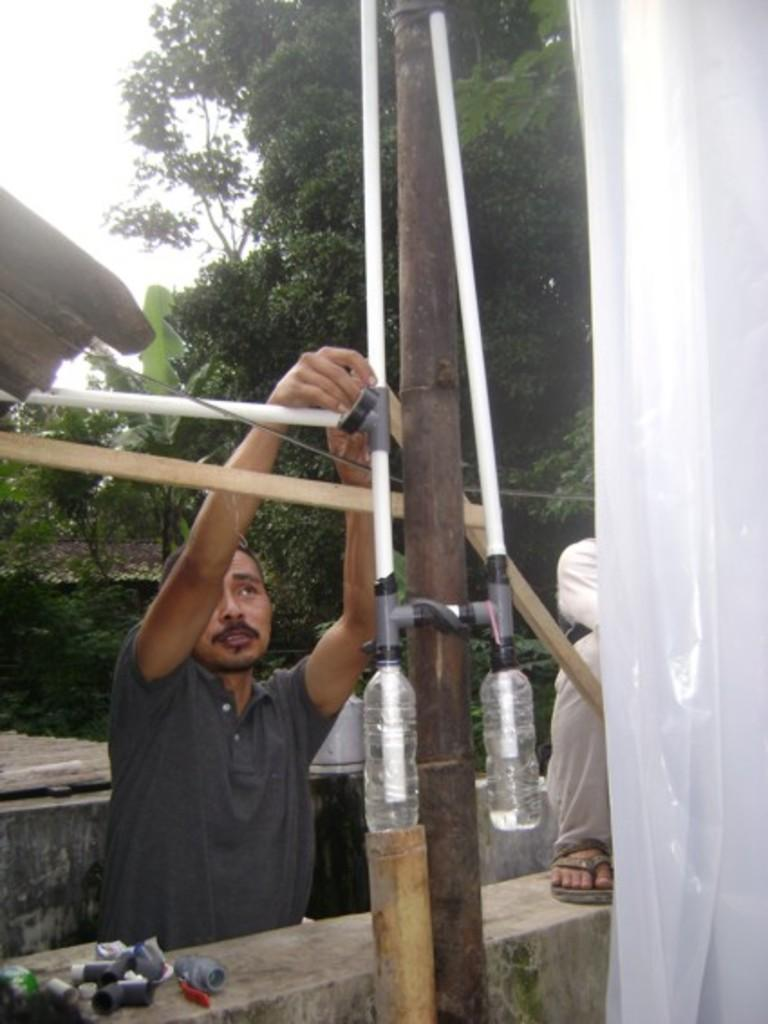Who or what can be seen in the image? There are people in the image. What can be seen in the distance behind the people? There are trees, pipes, bottles, and logs in the background of the image. What is covering part of the scene in the image? There is a sheet in the image. What type of structure is present in the image? There is a wall in the image. What type of heart-shaped object can be seen in the image? There is no heart-shaped object present in the image. What thrilling activity are the people participating in within the image? The image does not depict any specific activity, so it cannot be determined if it is thrilling or not. 